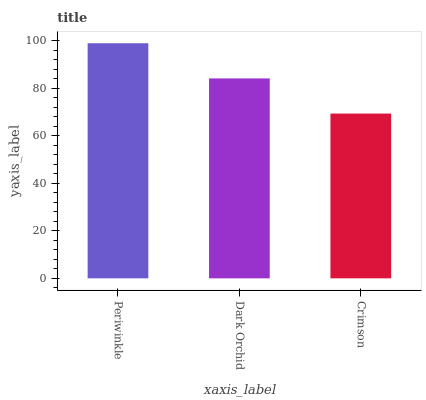Is Crimson the minimum?
Answer yes or no. Yes. Is Periwinkle the maximum?
Answer yes or no. Yes. Is Dark Orchid the minimum?
Answer yes or no. No. Is Dark Orchid the maximum?
Answer yes or no. No. Is Periwinkle greater than Dark Orchid?
Answer yes or no. Yes. Is Dark Orchid less than Periwinkle?
Answer yes or no. Yes. Is Dark Orchid greater than Periwinkle?
Answer yes or no. No. Is Periwinkle less than Dark Orchid?
Answer yes or no. No. Is Dark Orchid the high median?
Answer yes or no. Yes. Is Dark Orchid the low median?
Answer yes or no. Yes. Is Crimson the high median?
Answer yes or no. No. Is Periwinkle the low median?
Answer yes or no. No. 